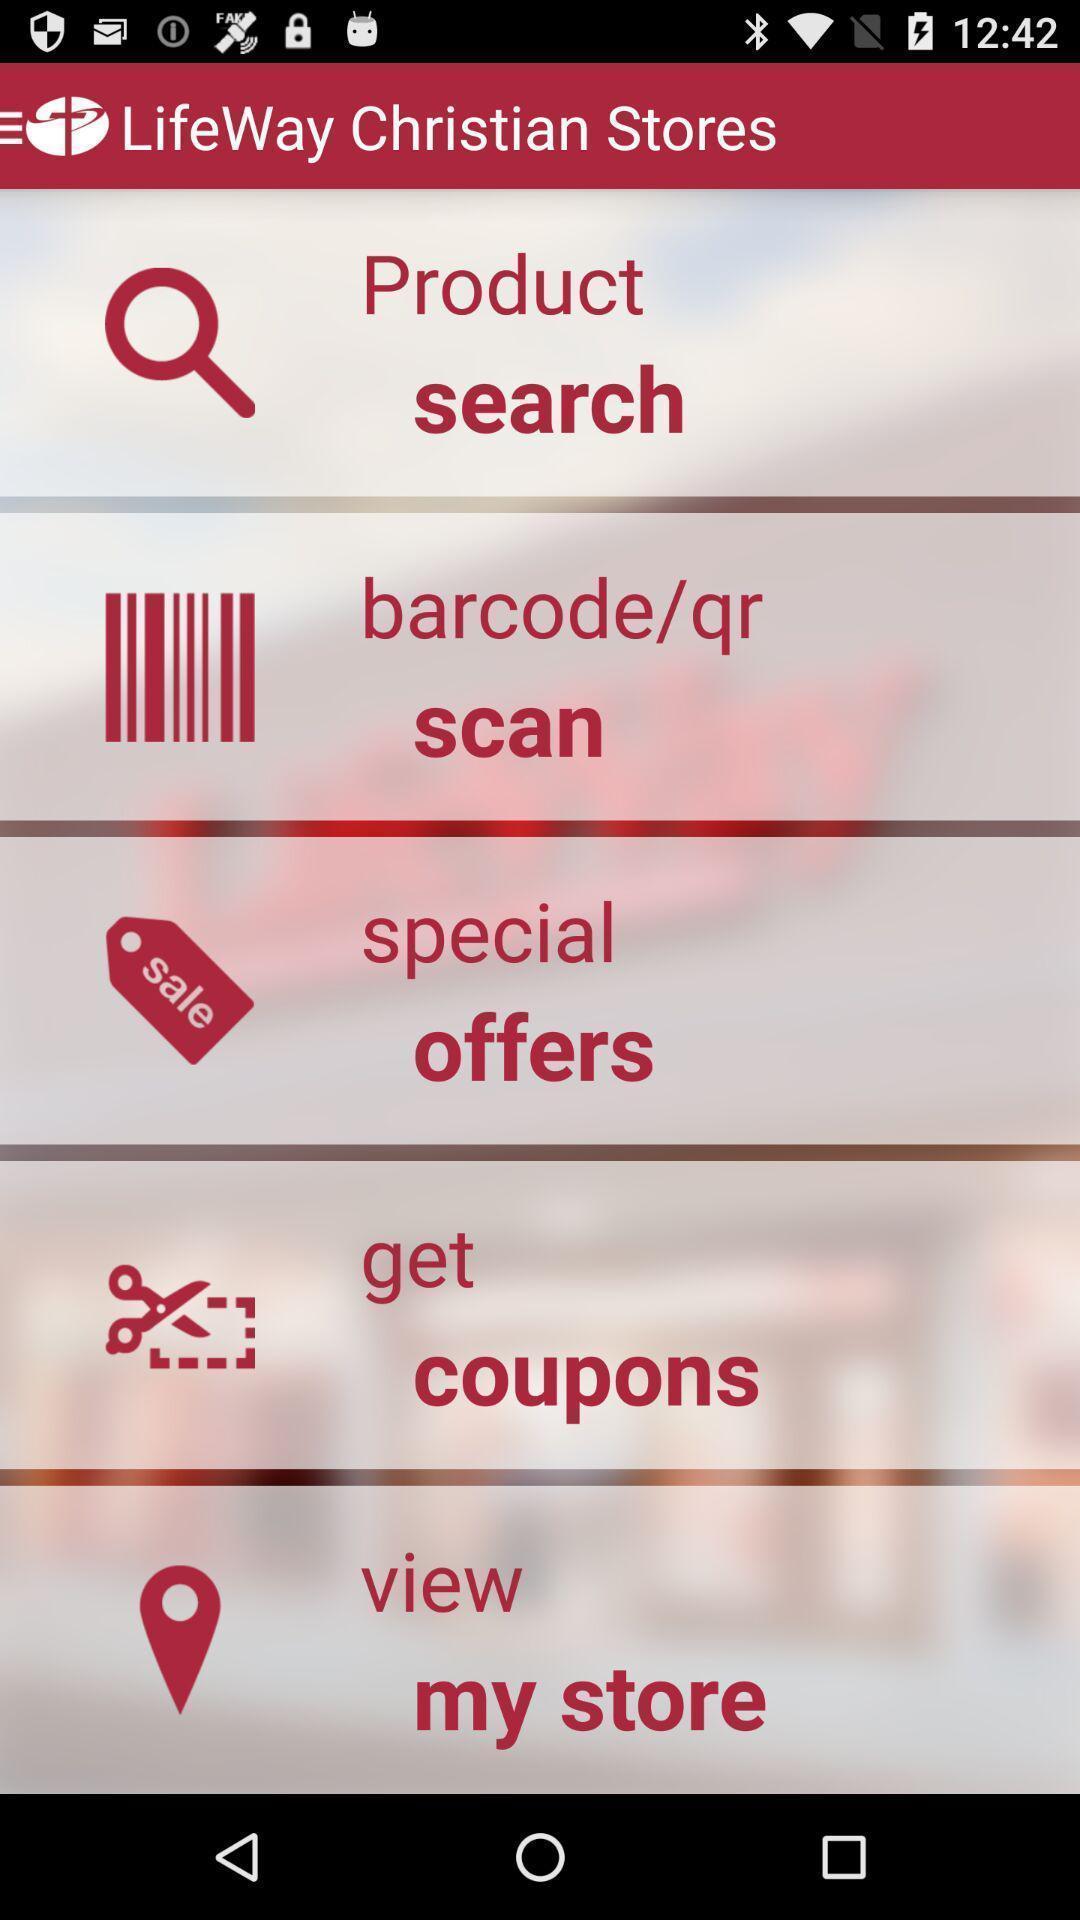Summarize the information in this screenshot. Screen page of a shopping application. 